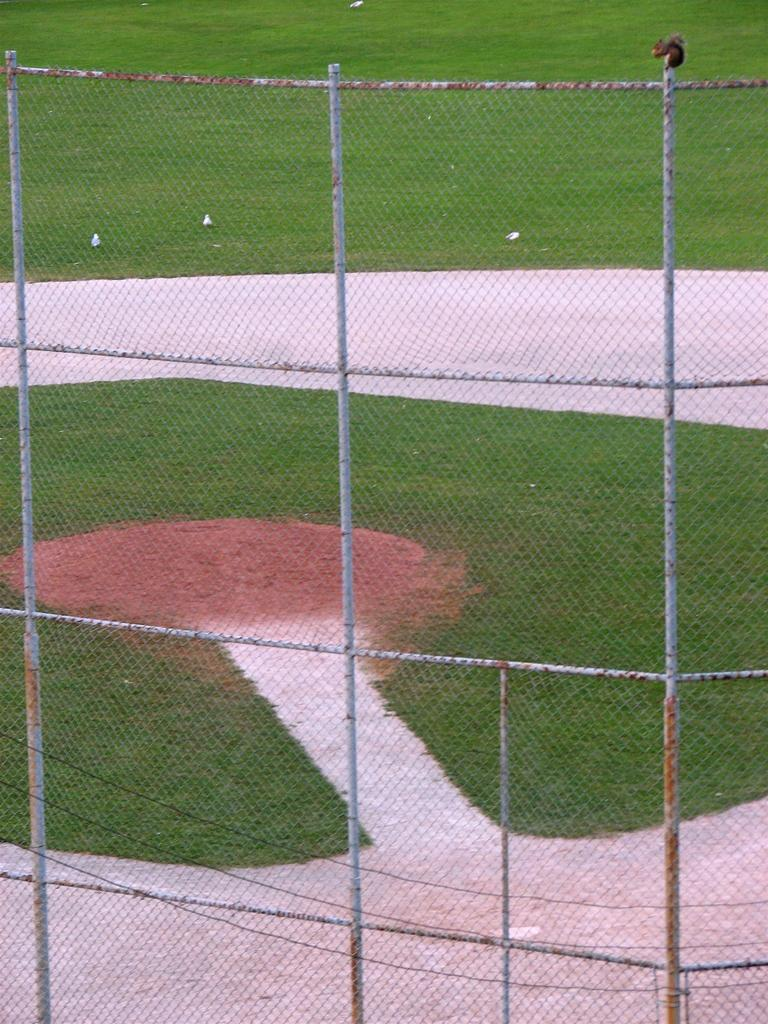What animal can be seen on the metal fence in the image? There is a squirrel on a metal fence in the image. What is visible in the background of the image? There are birds on a grass field in the background of the image. What type of finger can be seen holding the kite in the image? There is no kite or finger present in the image; it features a squirrel on a metal fence and birds on a grass field in the background. 